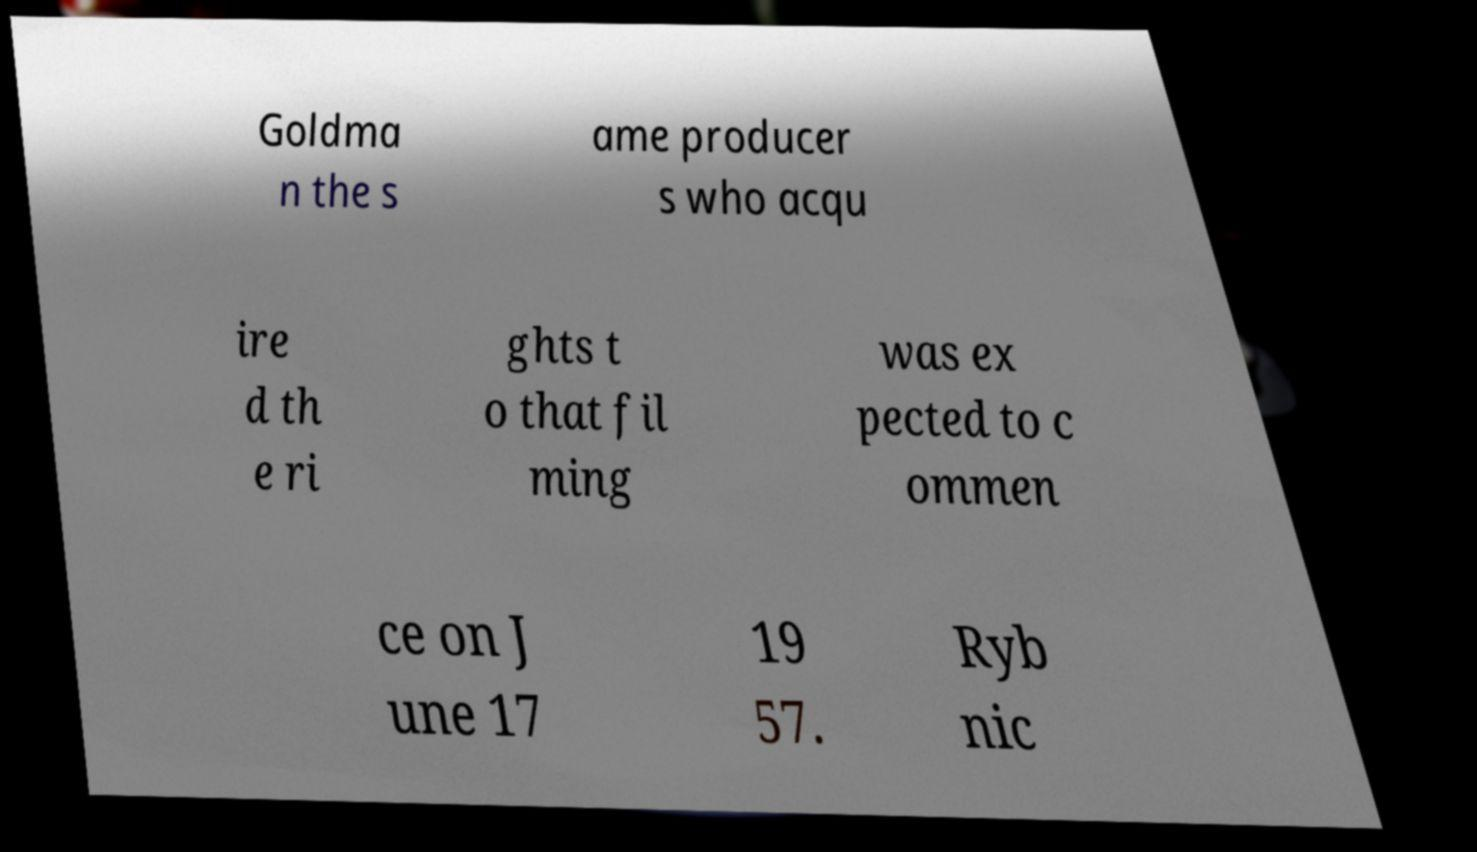What messages or text are displayed in this image? I need them in a readable, typed format. Goldma n the s ame producer s who acqu ire d th e ri ghts t o that fil ming was ex pected to c ommen ce on J une 17 19 57. Ryb nic 